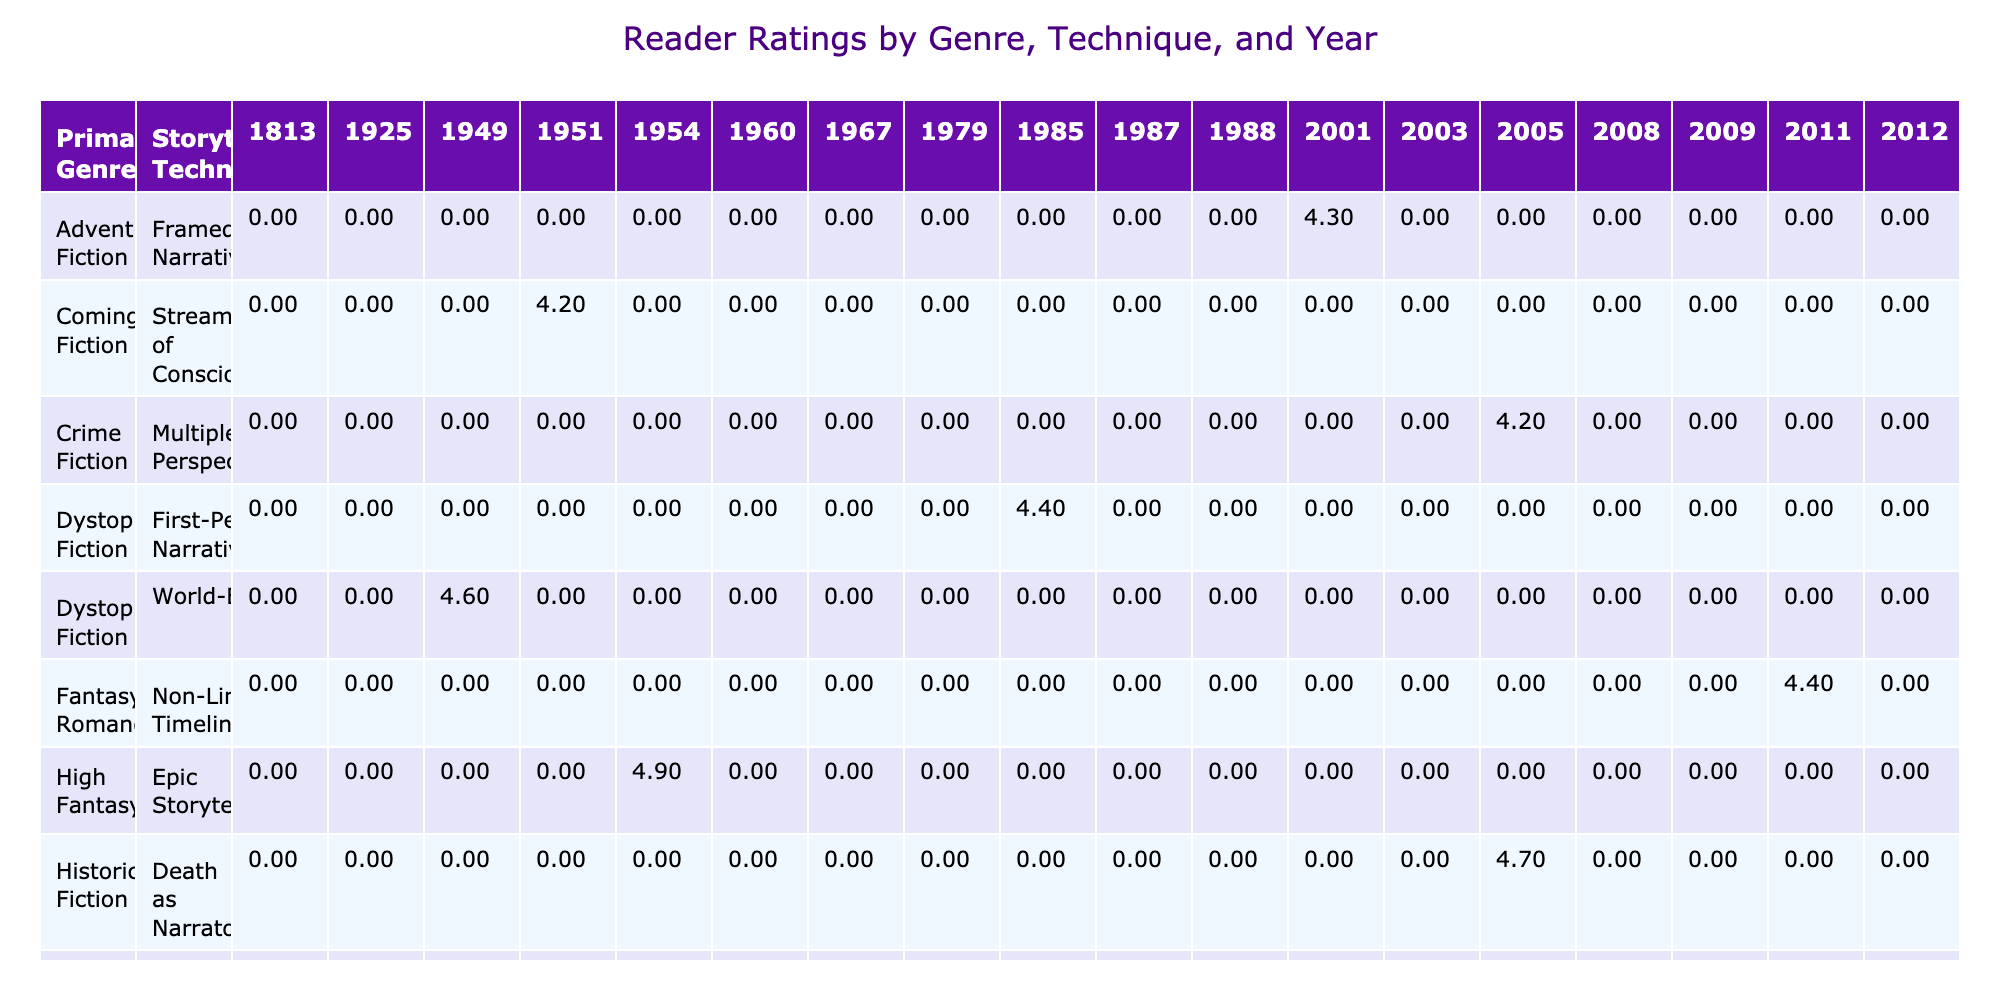What is the storytelling technique used in "The Great Gatsby"? The table lists the novel "The Great Gatsby" along with its corresponding storytelling technique under the column "Storytelling Technique." By locating the row for "The Great Gatsby," we see that the technique is labeled as "Unreliable Narrator."
Answer: Unreliable Narrator Which novel has the highest reader rating in the coming-of-age genre? To find the novel with the highest rating within the "Coming-of-Age Fiction" genre, we look under the column for "Reader Rating" specifically for this genre. The novels listed are "To Kill a Mockingbird" with a rating of 4.8 and "The Catcher in the Rye" with a rating of 4.2. Since 4.8 is higher than 4.2, "To Kill a Mockingbird" has the highest rating.
Answer: To Kill a Mockingbird Is "The Lord of the Rings" more critically acclaimed than "The Catcher in the Rye"? To answer this question, we check the "Critical Acclaim" column for both novels. "The Lord of the Rings" has a score of 9.6, while "The Catcher in the Rye" has 8.9. Since 9.6 is greater than 8.9, we conclude that "The Lord of the Rings" is indeed more critically acclaimed.
Answer: Yes What is the average reader rating for novels belonging to the High Fantasy genre? The table shows only one novel in the High Fantasy genre, which is "The Lord of the Rings," with a rating of 4.9. Since there is only one entry, the average rating is simply the rating of that one novel. Therefore, the average is 4.9.
Answer: 4.9 How many novels published in the 2000s have a rating greater than 4.5? First, we identify the novels published between 2000 and 2009: "The Kite Runner," "The Hunger Games," "The Book Thief," "The Fault in Our Stars," and "The Help." Their ratings are 4.6, 4.3, 4.7, 4.5, and 4.6 respectively. Out of these, "The Kite Runner," "The Book Thief," and "The Help" have ratings greater than 4.5. This totals 3 novels.
Answer: 3 What is the difference in critical acclaim between "The Handmaid's Tale" and "The Hunger Games"? The critical acclaim scores according to the table are 9.0 for "The Handmaid's Tale" and 8.7 for "The Hunger Games." To find the difference, we subtract 8.7 from 9.0, resulting in a difference of 0.3.
Answer: 0.3 Which storytelling technique is used most frequently among the listed novels? From the table, we analyze the storytelling techniques used across the novels. We count the occurrences: "Framed Narrative" occurs twice, "Multiple Narrators" occurs twice, and other techniques occur once. Thus, "Framed Narrative" and "Multiple Narrators" are the most frequent techniques as they each appear twice.
Answer: Framed Narrative and Multiple Narrators In what year was the novel with the lowest reader rating published? Looking through the reader ratings, "The Da Vinci Code" has the lowest rating of 4.0. Referring to the "Year Published" column for this novel, it shows that "The Da Vinci Code" was published in 2003.
Answer: 2003 